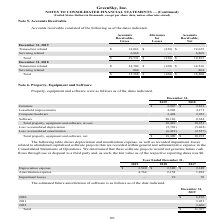From Greensky's financial document, Which years does the table show? The document shows two values: 2019 and 2018. From the document: "Accounts Receivable, Net December 31, 2019 Transaction related $ 12,863 $ (238) $ 12,625 Servicing related 6,868 — 6,868 Total $ 19,731 $ (238 ,868 To..." Also, What was the amount of Furniture in 2018? According to the financial document, 2,813 (in thousands). The relevant text states: "December 31, 2019 2018 Furniture $ 2,907 $ 2,813 Leasehold improvements 4,902 4,171 Computer hardware 2,494 2,923 Software 20,126 8,344 Total proper..." Also, What was the amount of Computer hardware in 2019? According to the financial document, 2,494 (in thousands). The relevant text states: "sehold improvements 4,902 4,171 Computer hardware 2,494 2,923 Software 20,126 8,344 Total property, equipment and software, at cost 30,429 18,251 Less: acc..." Also, How many years did Leasehold improvements exceed $4,000 thousand? Counting the relevant items in the document: 2019, 2018, I find 2 instances. The key data points involved are: 2018, 2019. Also, can you calculate: What was the change in the amount of Software between 2018 and 2019? Based on the calculation: 20,126-8,344, the result is 11782 (in thousands). This is based on the information: ",902 4,171 Computer hardware 2,494 2,923 Software 20,126 8,344 Total property, equipment and software, at cost 30,429 18,251 Less: accumulated depreciation 171 Computer hardware 2,494 2,923 Software 2..." The key data points involved are: 20,126, 8,344. Also, can you calculate: What was the percentage change in the net Total property, equipment and software between 2018 and 2019? To answer this question, I need to perform calculations using the financial data. The calculation is: (18,309-10,232)/10,232, which equals 78.94 (percentage). This is based on the information: "57) Total property, equipment and software, net $ 18,309 $ 10,232 property, equipment and software, net $ 18,309 $ 10,232..." The key data points involved are: 10,232, 18,309. 